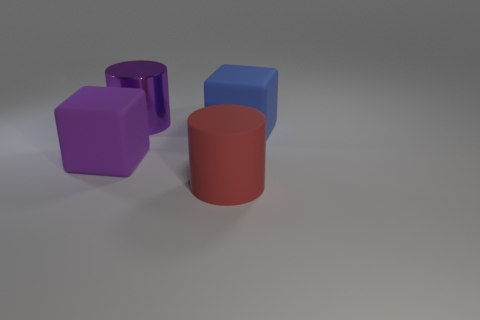Does the big metal cylinder have the same color as the rubber cylinder?
Keep it short and to the point. No. Is there a metal cylinder of the same color as the metallic object?
Your response must be concise. No. Does the big object that is behind the blue thing have the same material as the big cylinder that is in front of the purple rubber cube?
Make the answer very short. No. What color is the shiny thing?
Make the answer very short. Purple. There is a purple thing in front of the matte object that is behind the big rubber block left of the large blue rubber object; what size is it?
Provide a short and direct response. Large. How many other things are there of the same size as the red thing?
Your answer should be compact. 3. What number of other purple cylinders have the same material as the purple cylinder?
Your answer should be very brief. 0. What is the shape of the object that is behind the large blue matte cube?
Your answer should be very brief. Cylinder. Do the blue block and the block left of the red rubber cylinder have the same material?
Ensure brevity in your answer.  Yes. Are there any purple things?
Offer a terse response. Yes. 